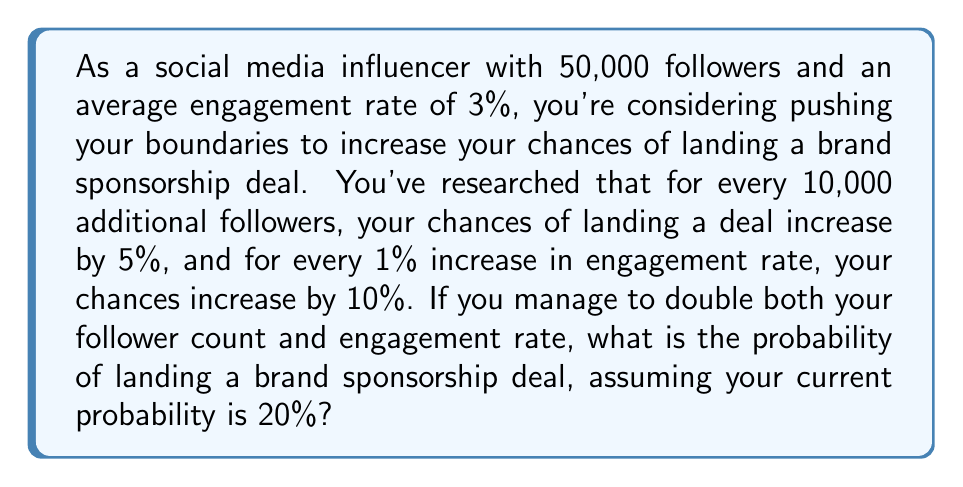Can you answer this question? Let's approach this problem step by step:

1. Current status:
   - Followers: 50,000
   - Engagement rate: 3%
   - Current probability of landing a deal: 20%

2. After doubling both metrics:
   - New follower count: 100,000 (increase of 50,000)
   - New engagement rate: 6% (increase of 3%)

3. Calculate the increase in probability due to follower increase:
   - Increase of 50,000 followers = 5 sets of 10,000
   - Each set increases probability by 5%
   - Total increase: $5 \times 5\% = 25\%$

4. Calculate the increase in probability due to engagement rate increase:
   - Increase of 3% in engagement rate
   - Each 1% increases probability by 10%
   - Total increase: $3 \times 10\% = 30\%$

5. Calculate the new probability:
   Let $p$ be the new probability.
   $$p = 20\% + 25\% + 30\% = 75\%$$

   However, we need to be careful here. Probability cannot exceed 100%. In this case, the sum is less than 100%, so we don't need to adjust our calculation.

Therefore, the new probability of landing a brand sponsorship deal after doubling both follower count and engagement rate is 75%.
Answer: 75% 